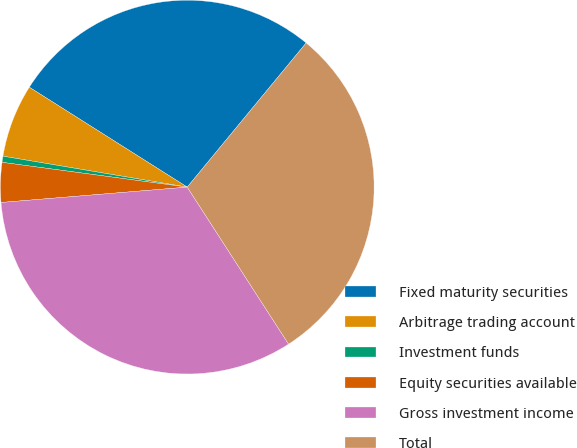Convert chart. <chart><loc_0><loc_0><loc_500><loc_500><pie_chart><fcel>Fixed maturity securities<fcel>Arbitrage trading account<fcel>Investment funds<fcel>Equity securities available<fcel>Gross investment income<fcel>Total<nl><fcel>27.0%<fcel>6.33%<fcel>0.53%<fcel>3.43%<fcel>32.81%<fcel>29.9%<nl></chart> 